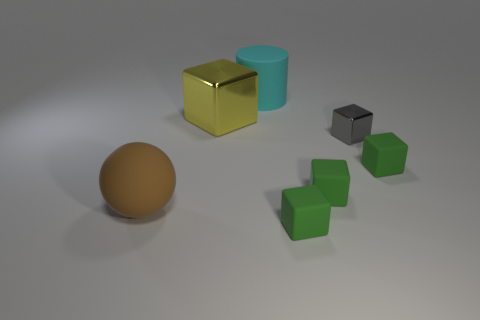What material is the large yellow thing?
Offer a terse response. Metal. How many large red cubes are there?
Make the answer very short. 0. Are there fewer yellow blocks than green matte objects?
Provide a short and direct response. Yes. There is a yellow object that is the same size as the cyan cylinder; what is its material?
Offer a very short reply. Metal. How many objects are either large blue rubber cubes or big matte objects?
Keep it short and to the point. 2. How many objects are both right of the large metallic cube and behind the big matte sphere?
Provide a short and direct response. 4. Are there fewer cylinders in front of the cyan cylinder than big cyan rubber things?
Give a very brief answer. Yes. There is a cyan matte thing that is the same size as the yellow shiny cube; what is its shape?
Give a very brief answer. Cylinder. How many other things are the same color as the matte ball?
Your answer should be compact. 0. Is the cyan matte thing the same size as the matte ball?
Make the answer very short. Yes. 